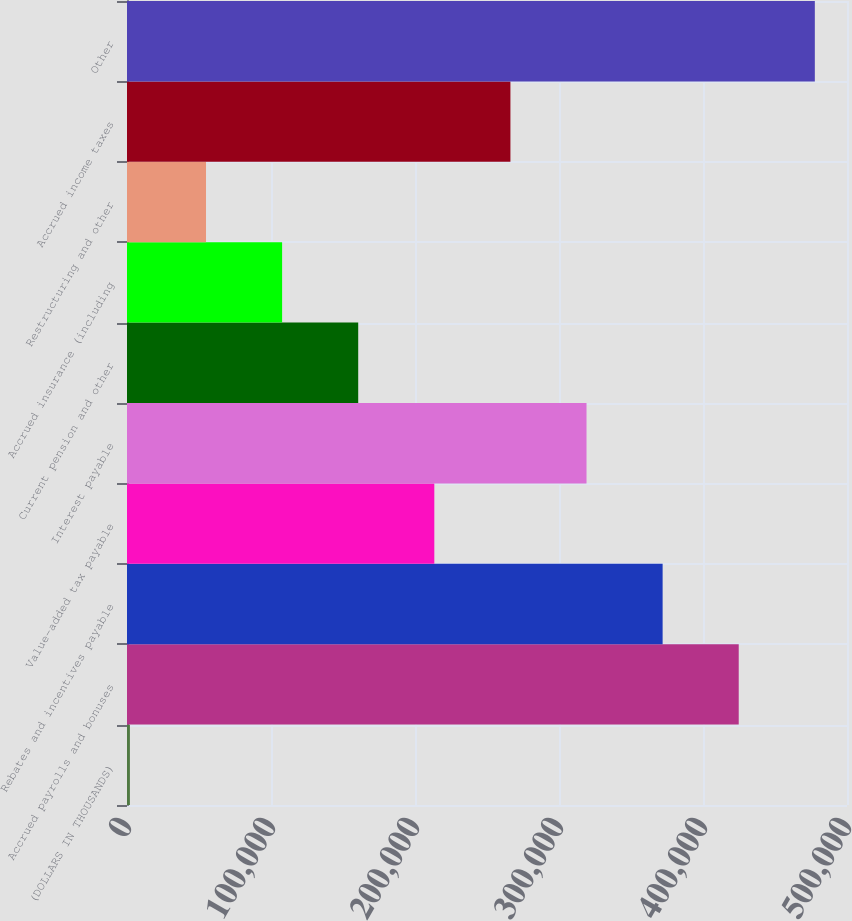Convert chart to OTSL. <chart><loc_0><loc_0><loc_500><loc_500><bar_chart><fcel>(DOLLARS IN THOUSANDS)<fcel>Accrued payrolls and bonuses<fcel>Rebates and incentives payable<fcel>Value-added tax payable<fcel>Interest payable<fcel>Current pension and other<fcel>Accrued insurance (including<fcel>Restructuring and other<fcel>Accrued income taxes<fcel>Other<nl><fcel>2018<fcel>424810<fcel>371961<fcel>213414<fcel>319112<fcel>160565<fcel>107716<fcel>54867<fcel>266263<fcel>477659<nl></chart> 